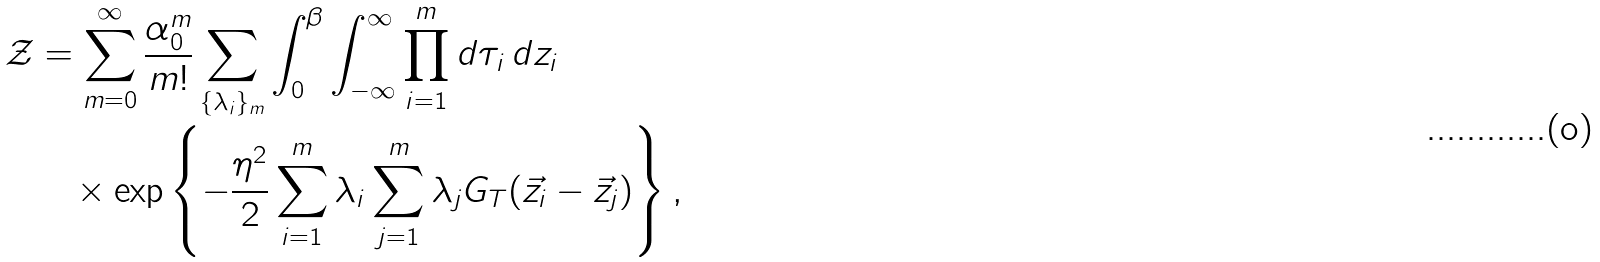<formula> <loc_0><loc_0><loc_500><loc_500>\mathcal { Z } & = \sum _ { m = 0 } ^ { \infty } \frac { \alpha _ { 0 } ^ { m } } { m ! } \sum _ { \{ \lambda _ { i } \} _ { m } } \int _ { 0 } ^ { \beta } \int _ { - \infty } ^ { \infty } \prod _ { i = 1 } ^ { m } d \tau _ { i } \, d z _ { i } \\ & \quad \times \exp \left \{ - \frac { \eta ^ { 2 } } { 2 } \sum _ { i = 1 } ^ { m } \lambda _ { i } \sum _ { j = 1 } ^ { m } \lambda _ { j } G _ { T } ( \vec { z } _ { i } - \vec { z } _ { j } ) \right \} ,</formula> 